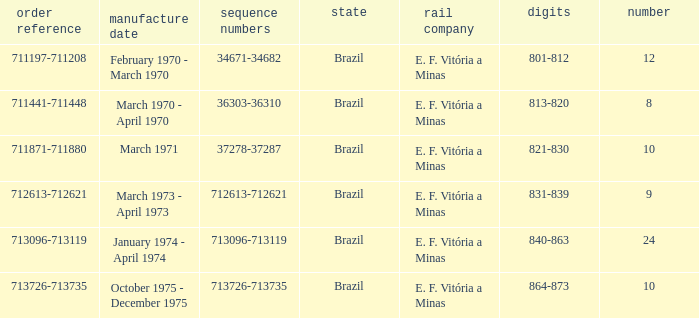How many railroads have the numbers 864-873? 1.0. 